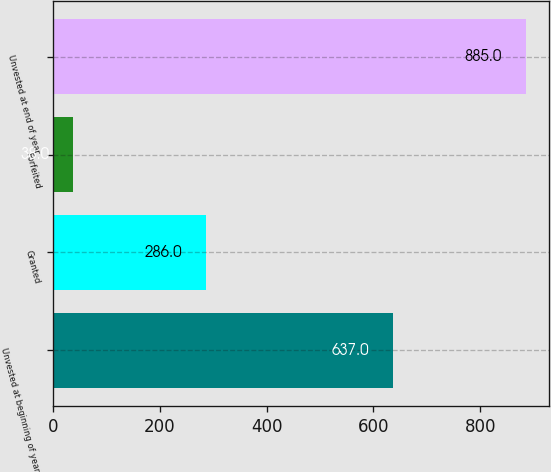Convert chart. <chart><loc_0><loc_0><loc_500><loc_500><bar_chart><fcel>Unvested at beginning of year<fcel>Granted<fcel>Forfeited<fcel>Unvested at end of year<nl><fcel>637<fcel>286<fcel>38<fcel>885<nl></chart> 